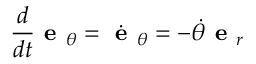Convert formula to latex. <formula><loc_0><loc_0><loc_500><loc_500>{ \frac { d } { d t } } { e } _ { \theta } = { \dot { e } } _ { \theta } = - { \dot { \theta } } { e } _ { r }</formula> 